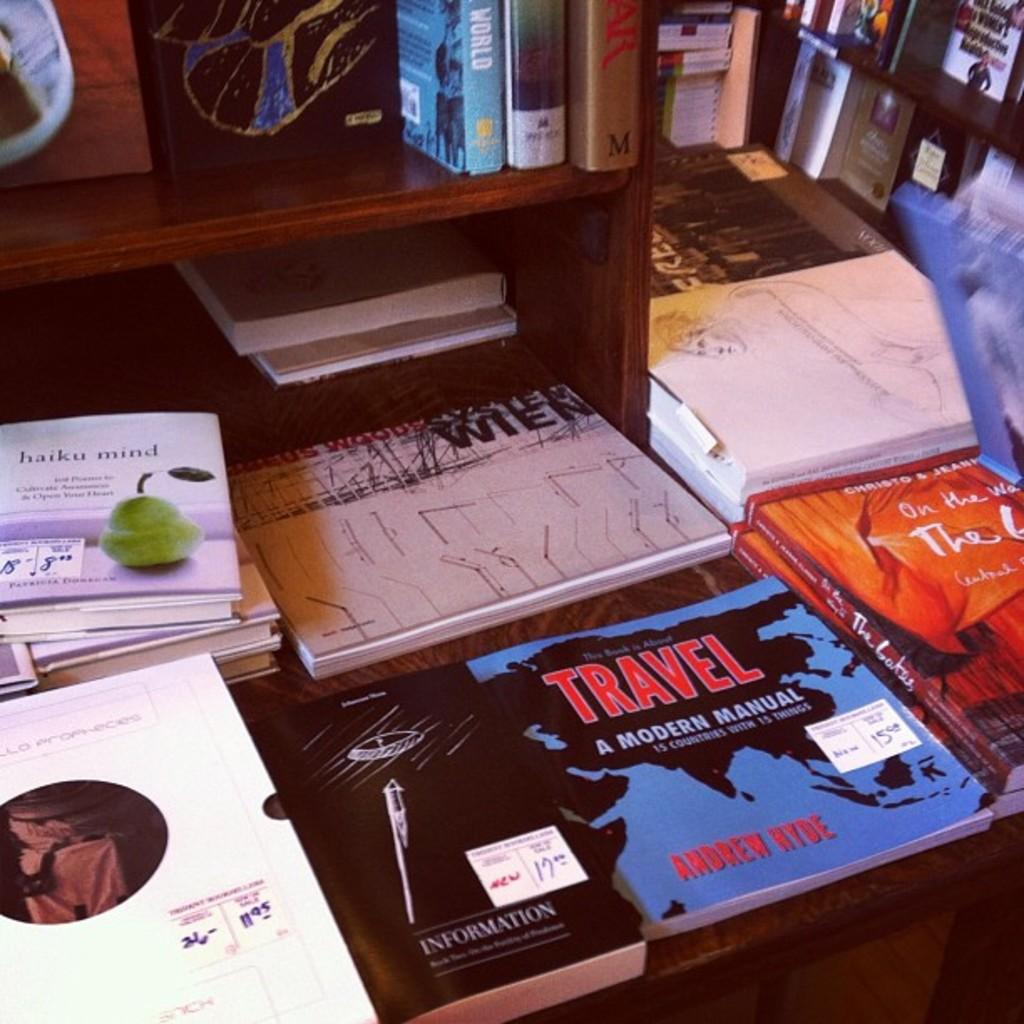<image>
Write a terse but informative summary of the picture. Travel a Modern Manual lays on a table with other books. 